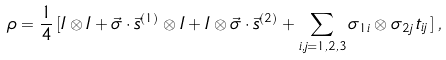<formula> <loc_0><loc_0><loc_500><loc_500>\rho = \frac { 1 } { 4 } \, [ I \otimes I + \vec { \sigma } \cdot \vec { s } ^ { ( 1 ) } \otimes I + I \otimes \vec { \sigma } \cdot \vec { s } ^ { ( 2 ) } + \sum _ { i , j = 1 , 2 , 3 } \sigma _ { 1 i } \otimes \sigma _ { 2 j } \, t _ { i j } \, ] \, ,</formula> 